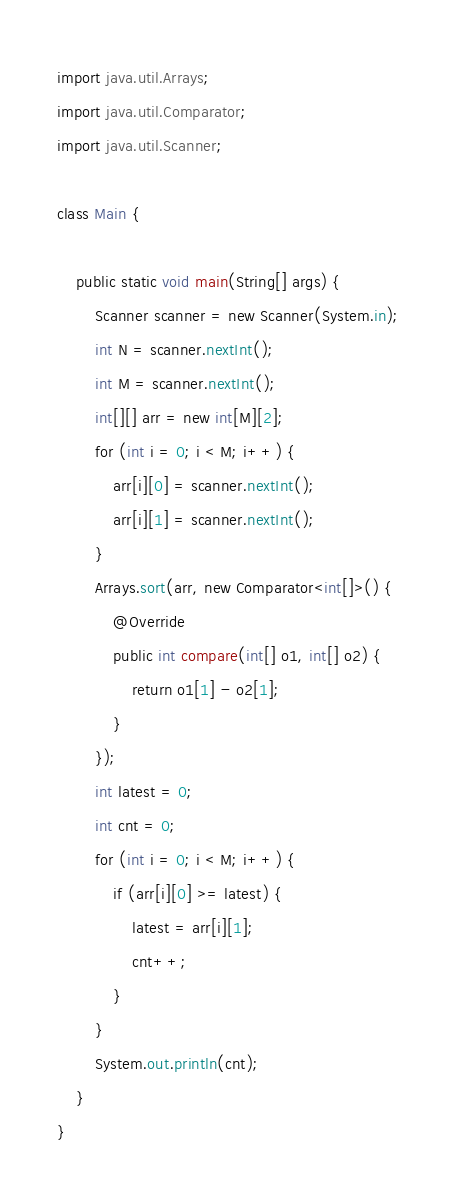Convert code to text. <code><loc_0><loc_0><loc_500><loc_500><_Java_>import java.util.Arrays;
import java.util.Comparator;
import java.util.Scanner;

class Main {

    public static void main(String[] args) {
        Scanner scanner = new Scanner(System.in);
        int N = scanner.nextInt();
        int M = scanner.nextInt();
        int[][] arr = new int[M][2];
        for (int i = 0; i < M; i++) {
            arr[i][0] = scanner.nextInt();
            arr[i][1] = scanner.nextInt();
        }
        Arrays.sort(arr, new Comparator<int[]>() {
            @Override
            public int compare(int[] o1, int[] o2) {
                return o1[1] - o2[1];
            }
        });
        int latest = 0;
        int cnt = 0;
        for (int i = 0; i < M; i++) {
            if (arr[i][0] >= latest) {
                latest = arr[i][1];
                cnt++;
            }
        }
        System.out.println(cnt);
    }
}</code> 